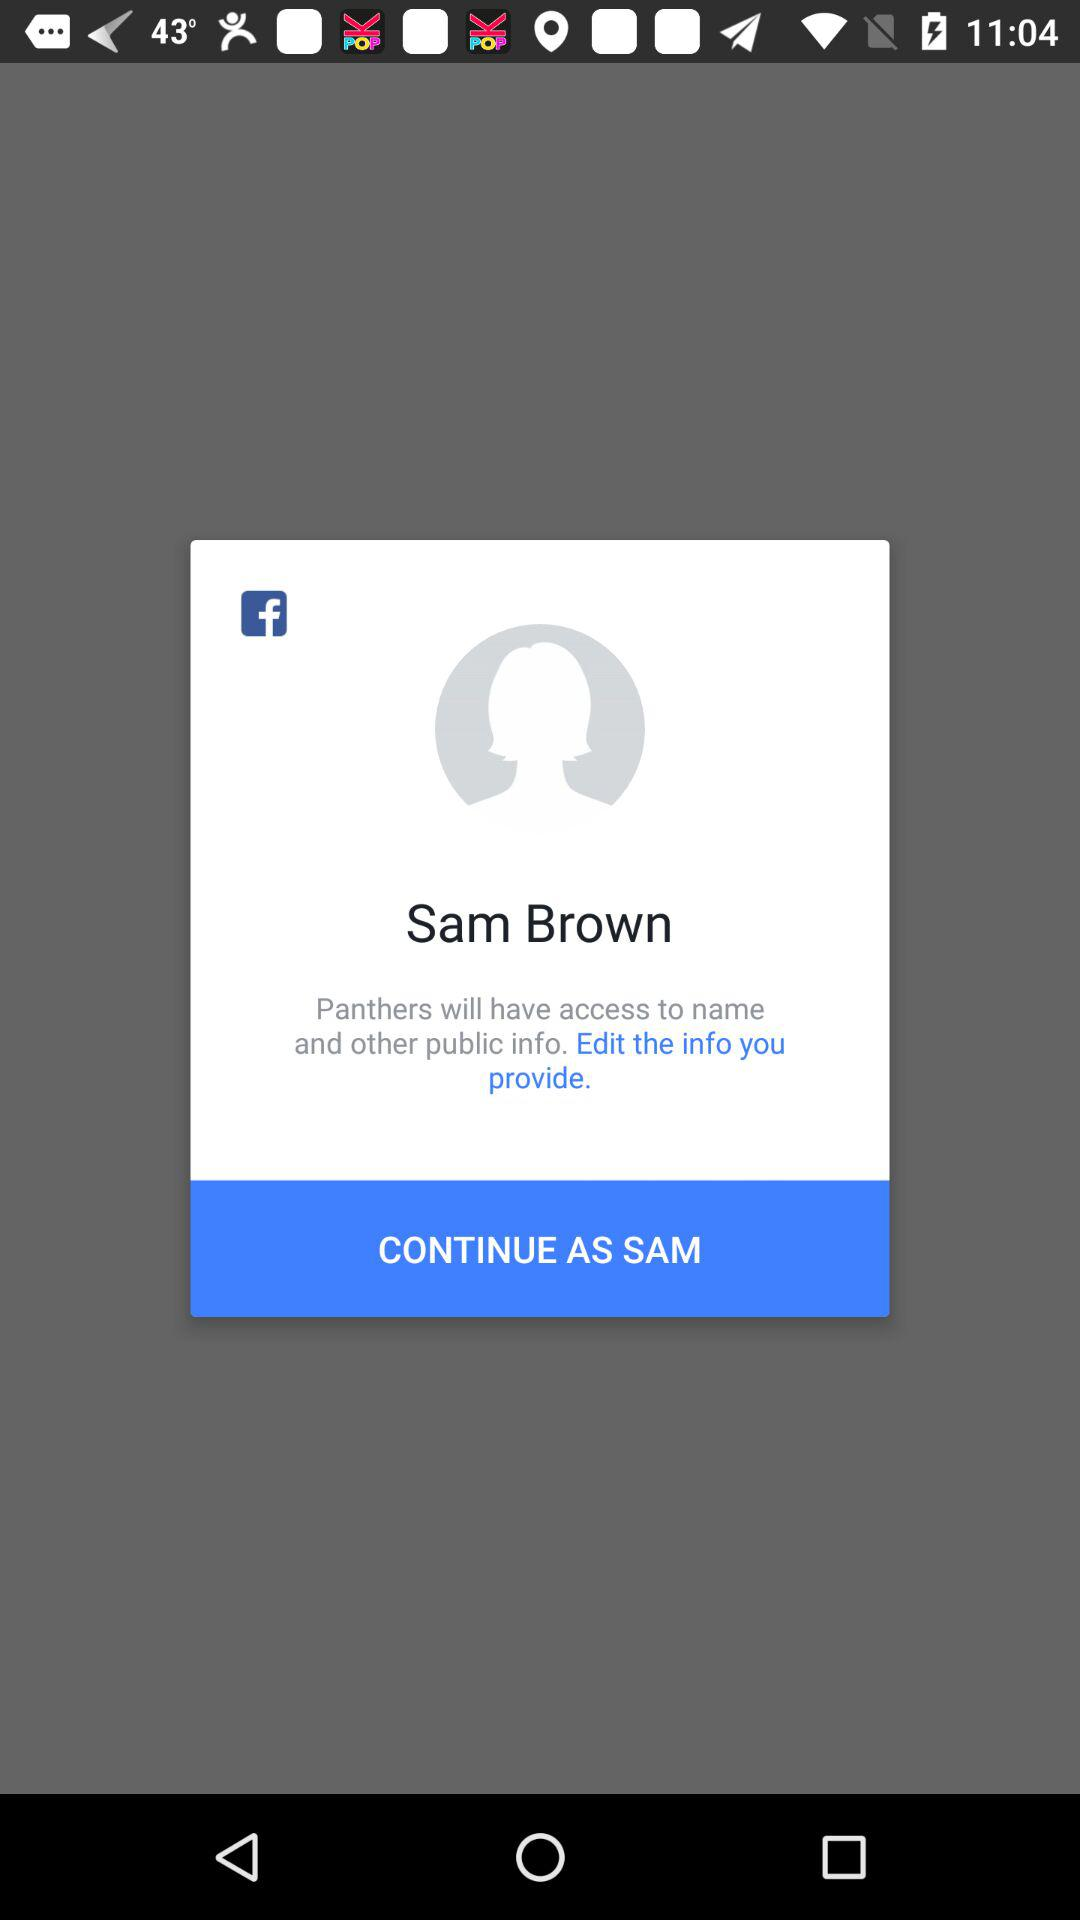What is the name of the user? The name of the user is Sam Brown. 